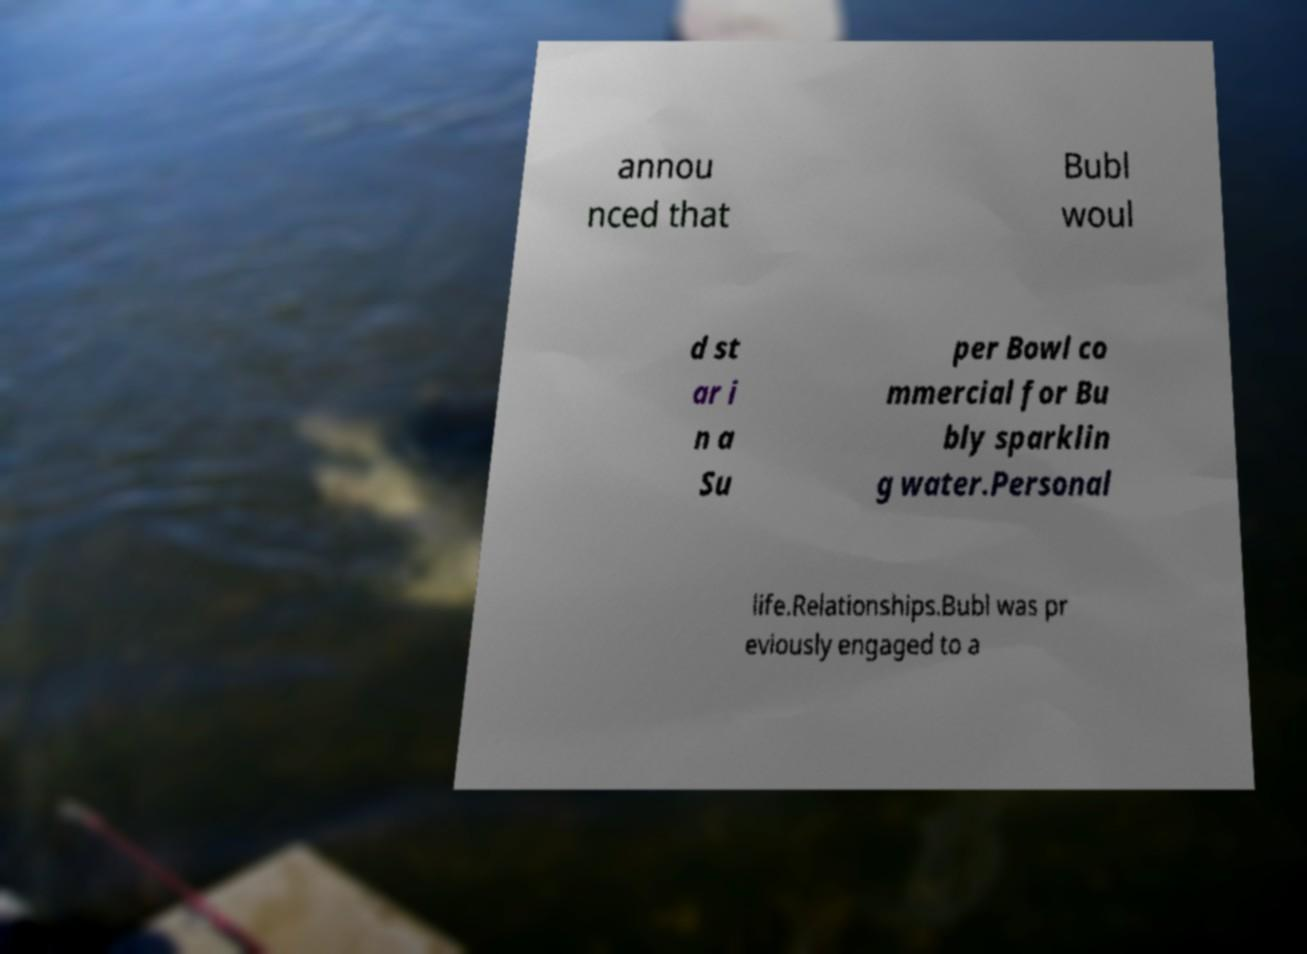Could you assist in decoding the text presented in this image and type it out clearly? annou nced that Bubl woul d st ar i n a Su per Bowl co mmercial for Bu bly sparklin g water.Personal life.Relationships.Bubl was pr eviously engaged to a 